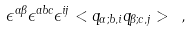Convert formula to latex. <formula><loc_0><loc_0><loc_500><loc_500>\epsilon ^ { \alpha \beta } \epsilon ^ { a b c } \epsilon ^ { i j } < q _ { \alpha ; b , i } q _ { \beta ; c , j } > \ ,</formula> 